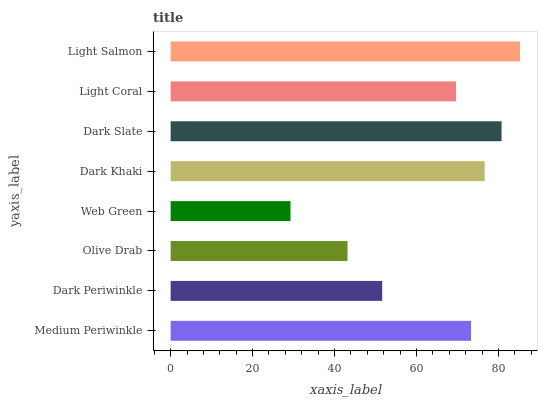Is Web Green the minimum?
Answer yes or no. Yes. Is Light Salmon the maximum?
Answer yes or no. Yes. Is Dark Periwinkle the minimum?
Answer yes or no. No. Is Dark Periwinkle the maximum?
Answer yes or no. No. Is Medium Periwinkle greater than Dark Periwinkle?
Answer yes or no. Yes. Is Dark Periwinkle less than Medium Periwinkle?
Answer yes or no. Yes. Is Dark Periwinkle greater than Medium Periwinkle?
Answer yes or no. No. Is Medium Periwinkle less than Dark Periwinkle?
Answer yes or no. No. Is Medium Periwinkle the high median?
Answer yes or no. Yes. Is Light Coral the low median?
Answer yes or no. Yes. Is Dark Khaki the high median?
Answer yes or no. No. Is Dark Slate the low median?
Answer yes or no. No. 